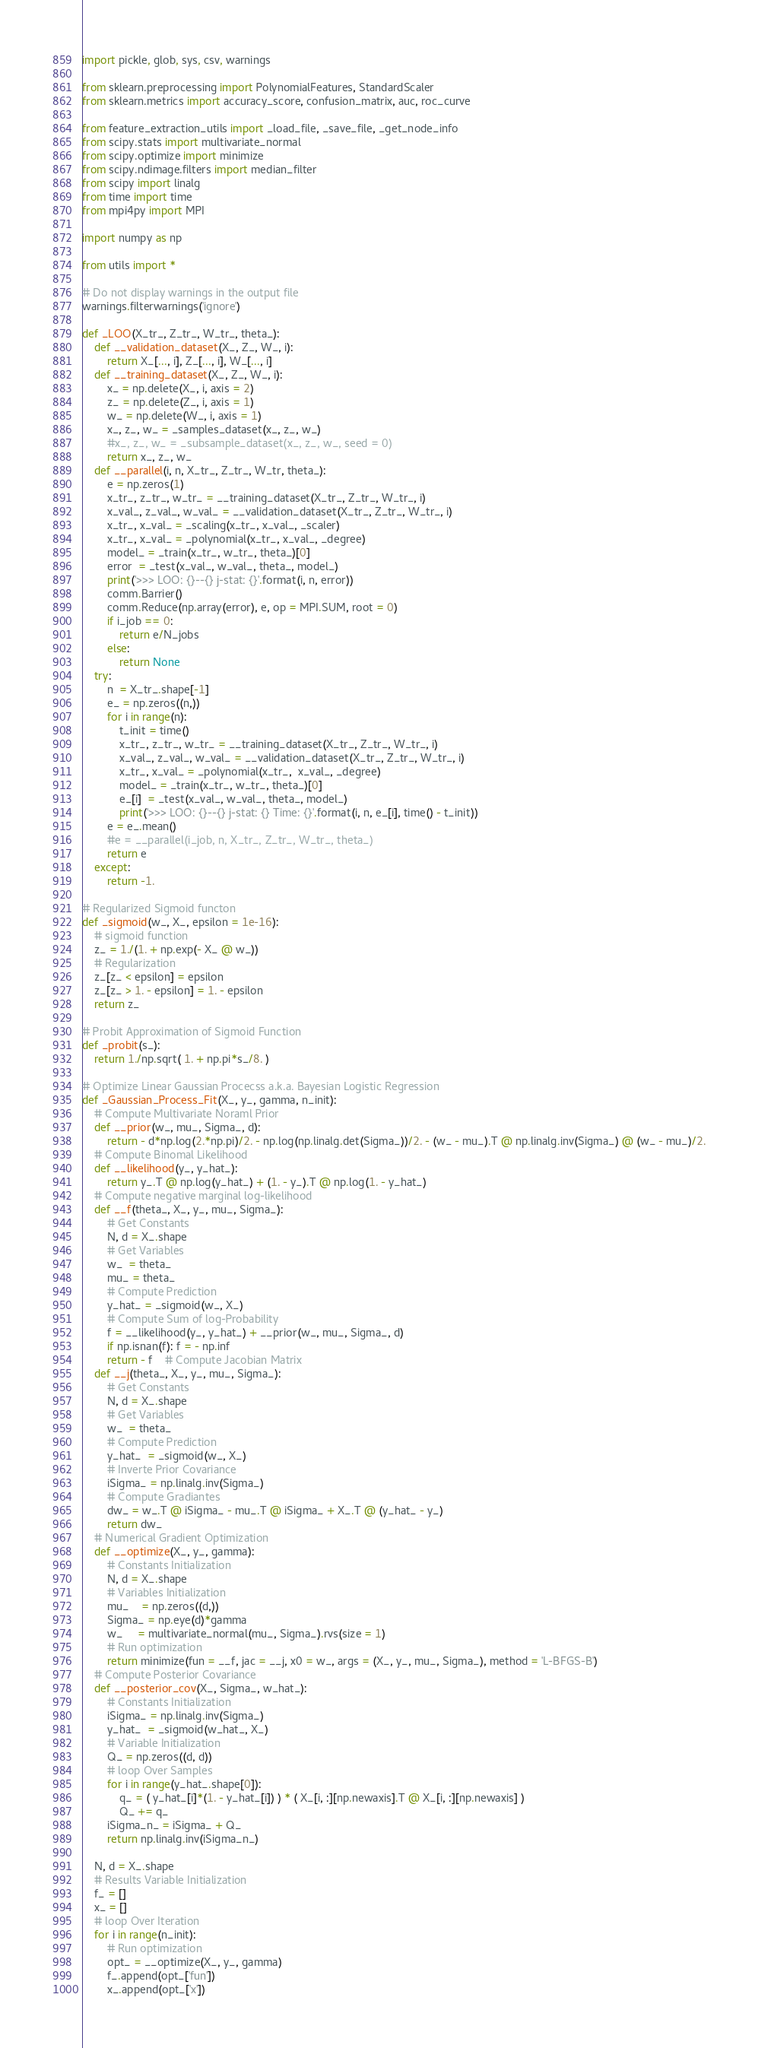<code> <loc_0><loc_0><loc_500><loc_500><_Python_>import pickle, glob, sys, csv, warnings

from sklearn.preprocessing import PolynomialFeatures, StandardScaler
from sklearn.metrics import accuracy_score, confusion_matrix, auc, roc_curve

from feature_extraction_utils import _load_file, _save_file, _get_node_info
from scipy.stats import multivariate_normal
from scipy.optimize import minimize
from scipy.ndimage.filters import median_filter
from scipy import linalg
from time import time
from mpi4py import MPI

import numpy as np

from utils import *

# Do not display warnings in the output file
warnings.filterwarnings('ignore')

def _LOO(X_tr_, Z_tr_, W_tr_, theta_):
    def __validation_dataset(X_, Z_, W_, i):
        return X_[..., i], Z_[..., i], W_[..., i]
    def __training_dataset(X_, Z_, W_, i):
        x_ = np.delete(X_, i, axis = 2)
        z_ = np.delete(Z_, i, axis = 1)
        w_ = np.delete(W_, i, axis = 1)
        x_, z_, w_ = _samples_dataset(x_, z_, w_)
        #x_, z_, w_ = _subsample_dataset(x_, z_, w_, seed = 0)
        return x_, z_, w_
    def __parallel(i, n, X_tr_, Z_tr_, W_tr, theta_):
        e = np.zeros(1)
        x_tr_, z_tr_, w_tr_ = __training_dataset(X_tr_, Z_tr_, W_tr_, i)
        x_val_, z_val_, w_val_ = __validation_dataset(X_tr_, Z_tr_, W_tr_, i)
        x_tr_, x_val_ = _scaling(x_tr_, x_val_, _scaler)
        x_tr_, x_val_ = _polynomial(x_tr_, x_val_, _degree)
        model_ = _train(x_tr_, w_tr_, theta_)[0]
        error  = _test(x_val_, w_val_, theta_, model_)
        print('>>> LOO: {}--{} j-stat: {}'.format(i, n, error))
        comm.Barrier()
        comm.Reduce(np.array(error), e, op = MPI.SUM, root = 0)
        if i_job == 0:
            return e/N_jobs
        else:
            return None
    try:
        n  = X_tr_.shape[-1]
        e_ = np.zeros((n,))
        for i in range(n):
            t_init = time()
            x_tr_, z_tr_, w_tr_ = __training_dataset(X_tr_, Z_tr_, W_tr_, i)
            x_val_, z_val_, w_val_ = __validation_dataset(X_tr_, Z_tr_, W_tr_, i)
            x_tr_, x_val_ = _polynomial(x_tr_,  x_val_, _degree)
            model_ = _train(x_tr_, w_tr_, theta_)[0]
            e_[i]  = _test(x_val_, w_val_, theta_, model_)
            print('>>> LOO: {}--{} j-stat: {} Time: {}'.format(i, n, e_[i], time() - t_init))
        e = e_.mean()
        #e = __parallel(i_job, n, X_tr_, Z_tr_, W_tr_, theta_)
        return e
    except:
        return -1.

# Regularized Sigmoid functon
def _sigmoid(w_, X_, epsilon = 1e-16):
    # sigmoid function
    z_ = 1./(1. + np.exp(- X_ @ w_))
    # Regularization
    z_[z_ < epsilon] = epsilon
    z_[z_ > 1. - epsilon] = 1. - epsilon
    return z_

# Probit Approximation of Sigmoid Function
def _probit(s_):
    return 1./np.sqrt( 1. + np.pi*s_/8. )

# Optimize Linear Gaussian Procecss a.k.a. Bayesian Logistic Regression
def _Gaussian_Process_Fit(X_, y_, gamma, n_init):
    # Compute Multivariate Noraml Prior
    def __prior(w_, mu_, Sigma_, d):
        return - d*np.log(2.*np.pi)/2. - np.log(np.linalg.det(Sigma_))/2. - (w_ - mu_).T @ np.linalg.inv(Sigma_) @ (w_ - mu_)/2.
    # Compute Binomal Likelihood
    def __likelihood(y_, y_hat_):
        return y_.T @ np.log(y_hat_) + (1. - y_).T @ np.log(1. - y_hat_)
    # Compute negative marginal log-likelihood
    def __f(theta_, X_, y_, mu_, Sigma_):
        # Get Constants
        N, d = X_.shape
        # Get Variables
        w_  = theta_
        mu_ = theta_
        # Compute Prediction
        y_hat_ = _sigmoid(w_, X_)
        # Compute Sum of log-Probability
        f = __likelihood(y_, y_hat_) + __prior(w_, mu_, Sigma_, d)
        if np.isnan(f): f = - np.inf
        return - f    # Compute Jacobian Matrix
    def __j(theta_, X_, y_, mu_, Sigma_):
        # Get Constants
        N, d = X_.shape
        # Get Variables
        w_  = theta_
        # Compute Prediction
        y_hat_  = _sigmoid(w_, X_)
        # Inverte Prior Covariance
        iSigma_ = np.linalg.inv(Sigma_)
        # Compute Gradiantes
        dw_ = w_.T @ iSigma_ - mu_.T @ iSigma_ + X_.T @ (y_hat_ - y_)
        return dw_
    # Numerical Gradient Optimization
    def __optimize(X_, y_, gamma):
        # Constants Initialization
        N, d = X_.shape
        # Variables Initialization
        mu_    = np.zeros((d,))
        Sigma_ = np.eye(d)*gamma
        w_     = multivariate_normal(mu_, Sigma_).rvs(size = 1)
        # Run optimization
        return minimize(fun = __f, jac = __j, x0 = w_, args = (X_, y_, mu_, Sigma_), method = 'L-BFGS-B')
    # Compute Posterior Covariance
    def __posterior_cov(X_, Sigma_, w_hat_):
        # Constants Initialization
        iSigma_ = np.linalg.inv(Sigma_)
        y_hat_  = _sigmoid(w_hat_, X_)
        # Variable Initialization
        Q_ = np.zeros((d, d))
        # loop Over Samples
        for i in range(y_hat_.shape[0]):
            q_ = ( y_hat_[i]*(1. - y_hat_[i]) ) * ( X_[i, :][np.newaxis].T @ X_[i, :][np.newaxis] )
            Q_ += q_
        iSigma_n_ = iSigma_ + Q_
        return np.linalg.inv(iSigma_n_)

    N, d = X_.shape
    # Results Variable Initialization
    f_ = []
    x_ = []
    # loop Over Iteration
    for i in range(n_init):
        # Run optimization
        opt_ = __optimize(X_, y_, gamma)
        f_.append(opt_['fun'])
        x_.append(opt_['x'])</code> 